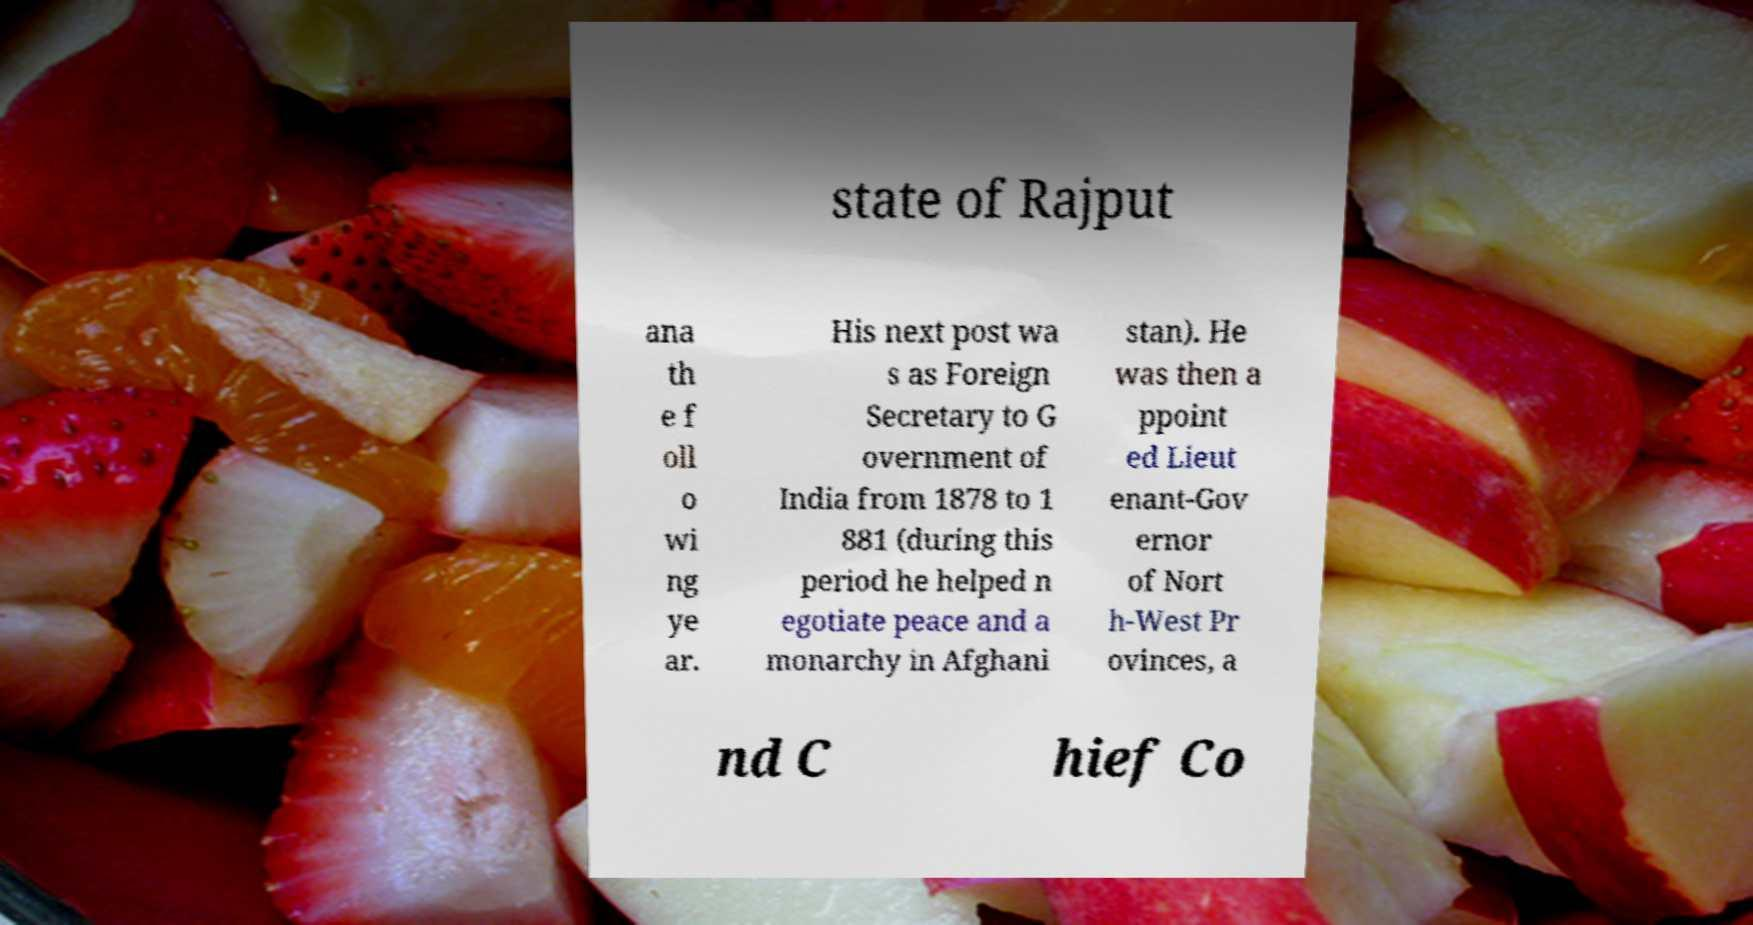There's text embedded in this image that I need extracted. Can you transcribe it verbatim? state of Rajput ana th e f oll o wi ng ye ar. His next post wa s as Foreign Secretary to G overnment of India from 1878 to 1 881 (during this period he helped n egotiate peace and a monarchy in Afghani stan). He was then a ppoint ed Lieut enant-Gov ernor of Nort h-West Pr ovinces, a nd C hief Co 